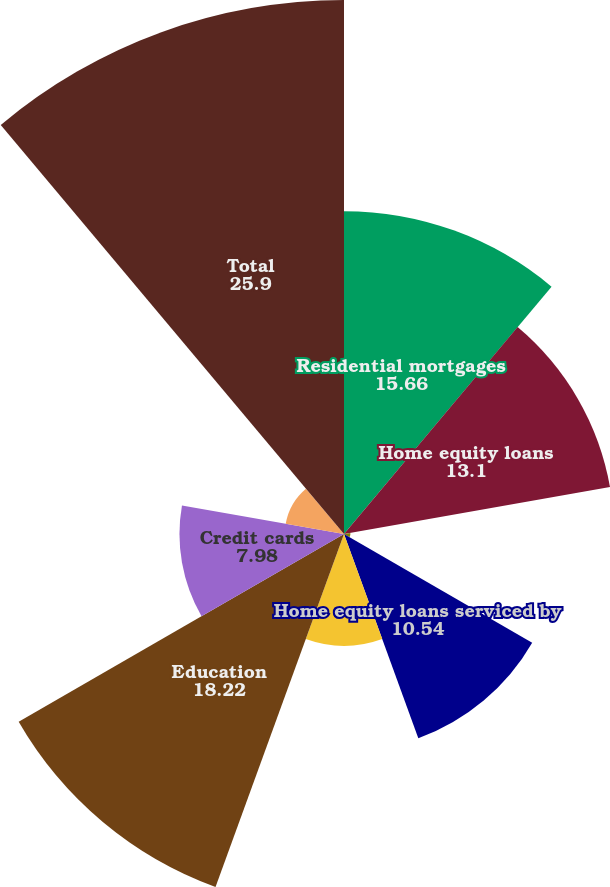Convert chart. <chart><loc_0><loc_0><loc_500><loc_500><pie_chart><fcel>Residential mortgages<fcel>Home equity loans<fcel>Home equity lines of credit<fcel>Home equity loans serviced by<fcel>Automobile<fcel>Education<fcel>Credit cards<fcel>Other retail<fcel>Total<nl><fcel>15.66%<fcel>13.1%<fcel>0.31%<fcel>10.54%<fcel>5.42%<fcel>18.22%<fcel>7.98%<fcel>2.87%<fcel>25.9%<nl></chart> 